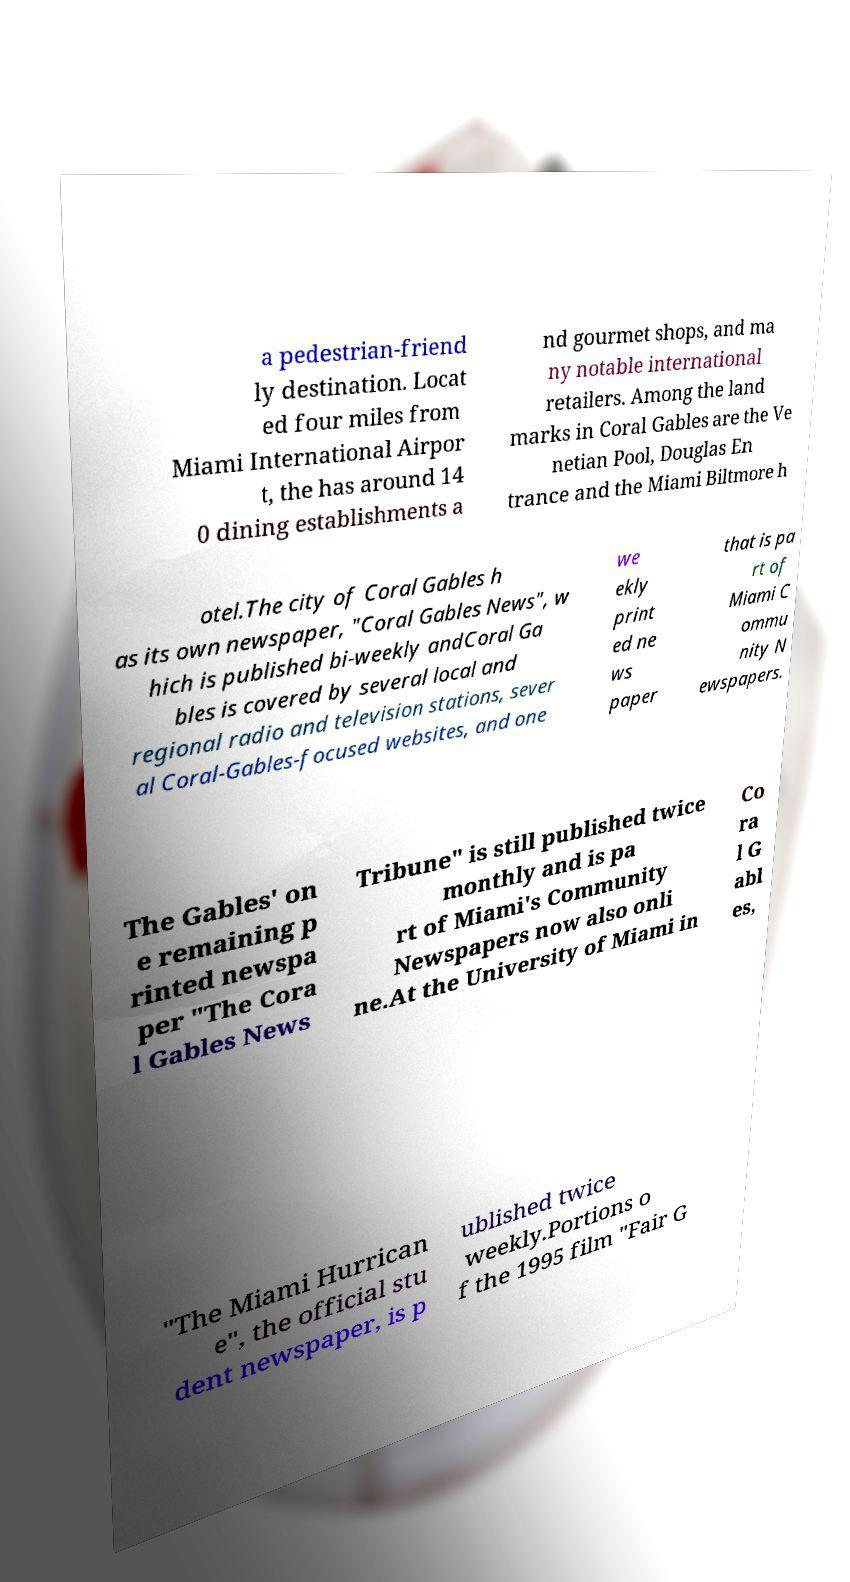Could you extract and type out the text from this image? a pedestrian-friend ly destination. Locat ed four miles from Miami International Airpor t, the has around 14 0 dining establishments a nd gourmet shops, and ma ny notable international retailers. Among the land marks in Coral Gables are the Ve netian Pool, Douglas En trance and the Miami Biltmore h otel.The city of Coral Gables h as its own newspaper, "Coral Gables News", w hich is published bi-weekly andCoral Ga bles is covered by several local and regional radio and television stations, sever al Coral-Gables-focused websites, and one we ekly print ed ne ws paper that is pa rt of Miami C ommu nity N ewspapers. The Gables' on e remaining p rinted newspa per "The Cora l Gables News Tribune" is still published twice monthly and is pa rt of Miami's Community Newspapers now also onli ne.At the University of Miami in Co ra l G abl es, "The Miami Hurrican e", the official stu dent newspaper, is p ublished twice weekly.Portions o f the 1995 film "Fair G 